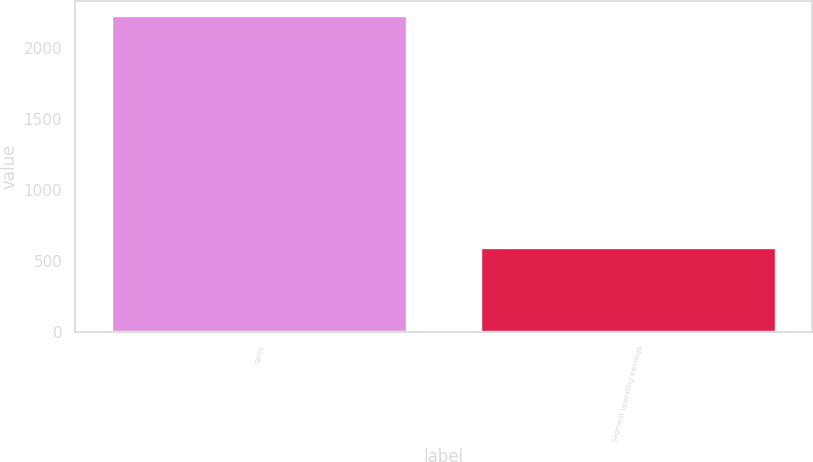Convert chart to OTSL. <chart><loc_0><loc_0><loc_500><loc_500><bar_chart><fcel>Sales<fcel>Segment operating earnings<nl><fcel>2221.3<fcel>587.7<nl></chart> 